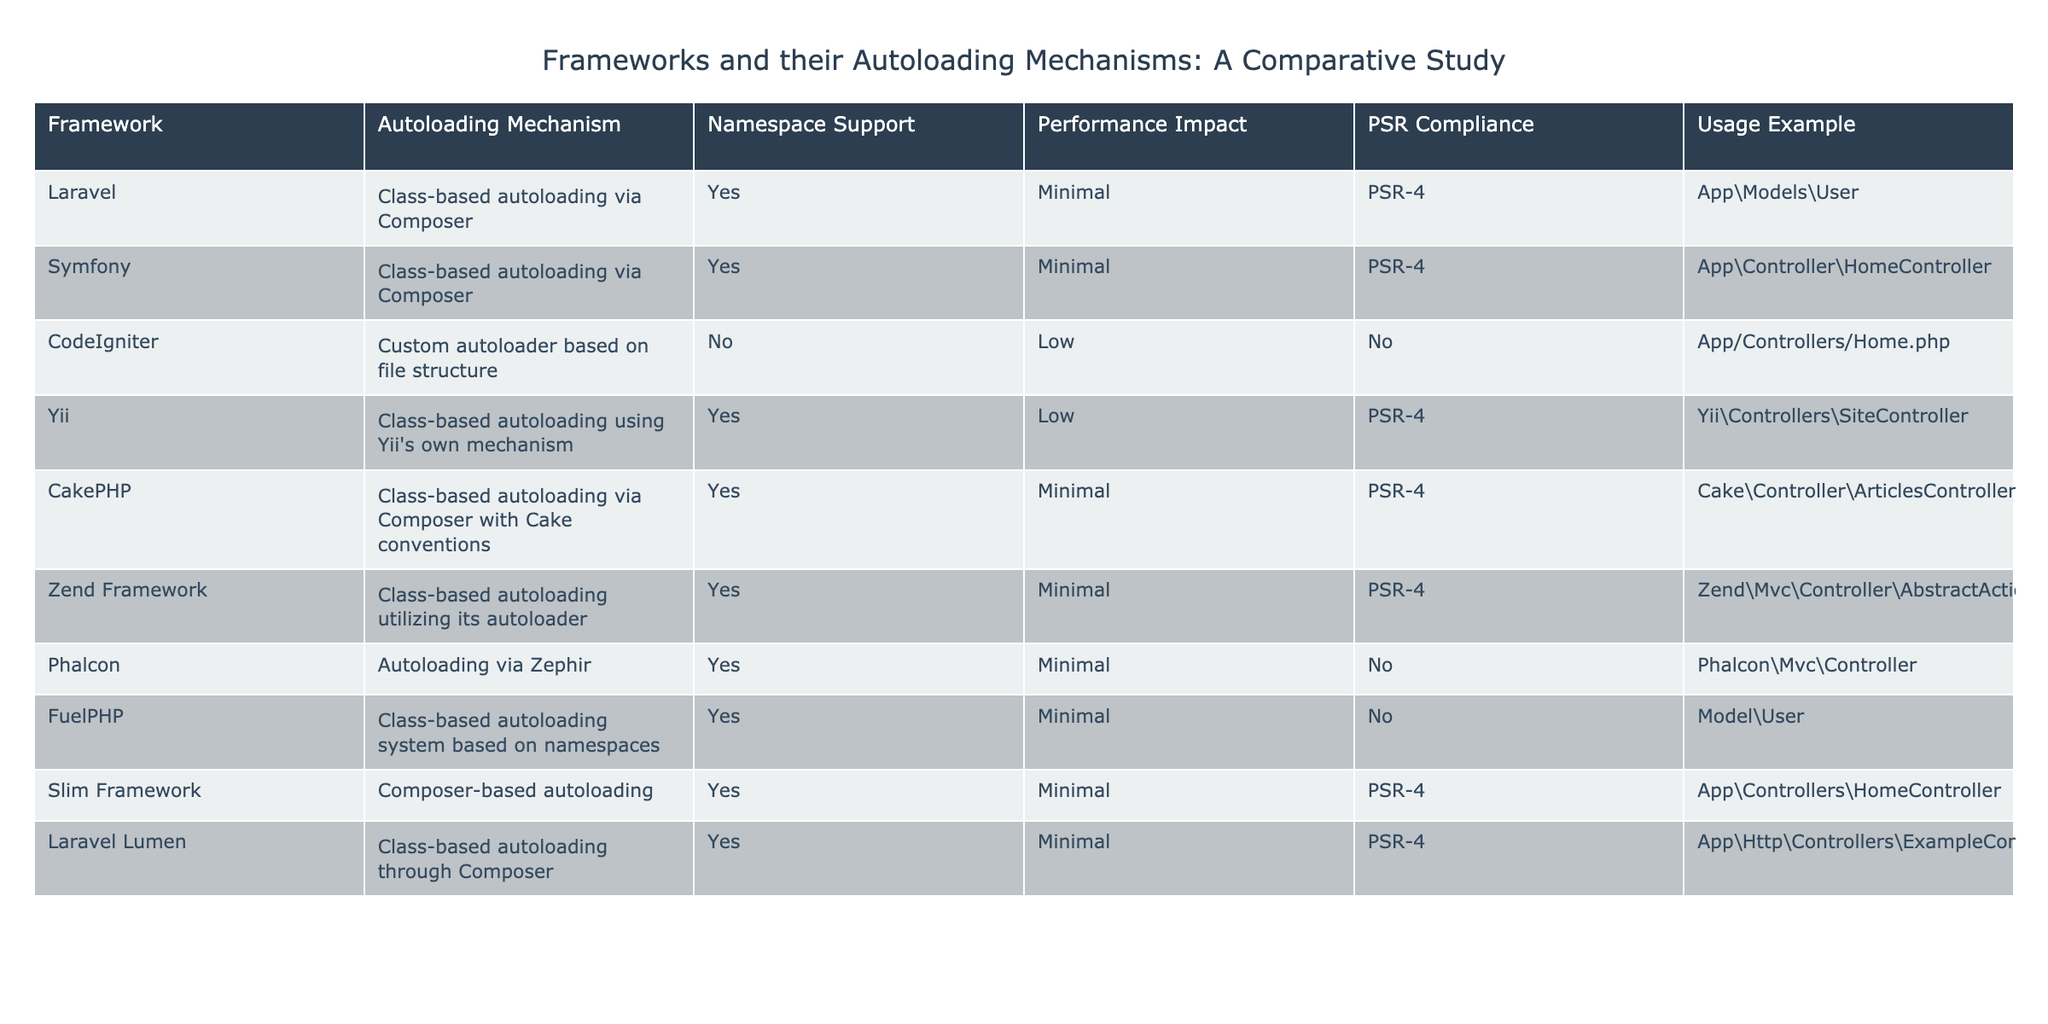What autoloading mechanism does Symfony use? From the table, we can see that Symfony utilizes class-based autoloading via Composer. This information is directly found in the "Autoloading Mechanism" column for the Symfony row.
Answer: Class-based autoloading via Composer Does CodeIgniter support namespaces? Checking the "Namespace Support" column for CodeIgniter, it is marked as "No." This indicates that CodeIgniter does not support namespaces in its autoloading mechanism.
Answer: No What is the performance impact of Yii's autoloading mechanism? In the table, the "Performance Impact" for Yii lists "Low." This means that there is a minor performance impact associated with Yii's autoloading mechanism.
Answer: Low How many frameworks in the table comply with PSR-4? Counting the number of rows in the table where the "PSR Compliance" column indicates "PSR-4," we find five frameworks: Laravel, Symfony, CakePHP, Zend Framework, and Slim Framework. Therefore, the total number of frameworks that comply with PSR-4 is five.
Answer: Five Which framework has the highest performance impact? By examining the "Performance Impact" column for all frameworks and noting that the highest ranking in the table is found with CodeIgniter, which has a "Low" impact. All frameworks listed have either "Minimal" or "Low," so in this case “Low” represents the highest performance impact compared to the rest.
Answer: Low Is there any framework listed that does not use Composer for autoloading? Looking at the "Autoloading Mechanism" for all frameworks, only CodeIgniter uses a custom autoloader not based on Composer. This answers the question affirmatively that at least one framework does not use Composer, namely CodeIgniter.
Answer: Yes What is the usage example for the Laravel framework? The "Usage Example" column for Laravel provides the example "App\Models\User." Here we have a concrete instance demonstrating how autoloading works in Laravel.
Answer: App\Models\User How many frameworks support namespaces based on the table data? Counting the number of frameworks that have "Yes" under the "Namespace Support" column gives us seven: Laravel, Symfony, Yii, CakePHP, Zend Framework, Phalcon, and FuelPHP. Thus, there are seven frameworks that support namespaces.
Answer: Seven Which framework has a class-based autoloading mechanism that is not PSR-compliant? From the table, the only framework with a class-based autoloading mechanism indicated as "No" in the "PSR Compliance" column is CodeIgniter. Therefore, it is the framework in question.
Answer: CodeIgniter 